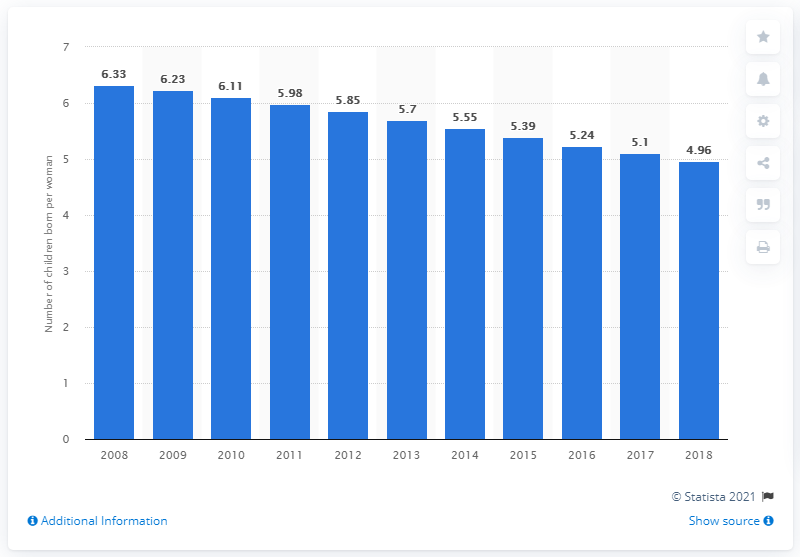Indicate a few pertinent items in this graphic. In 2018, Uganda's fertility rate was 4.96. 